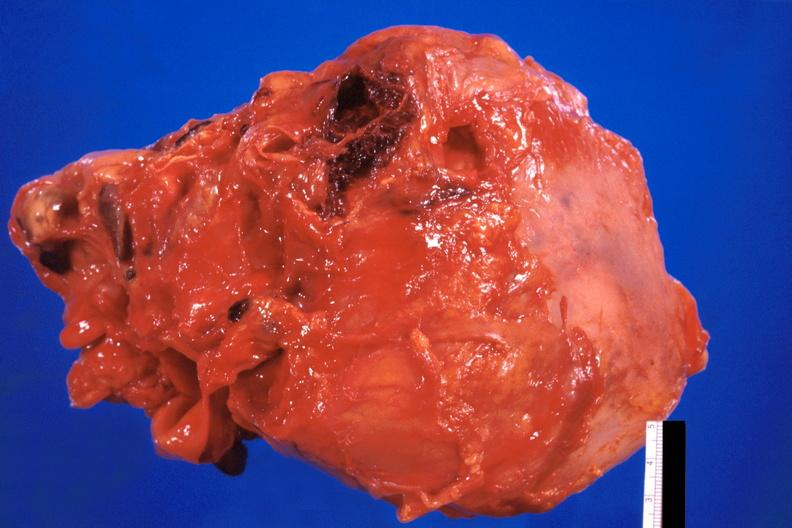where is this?
Answer the question using a single word or phrase. Heart 